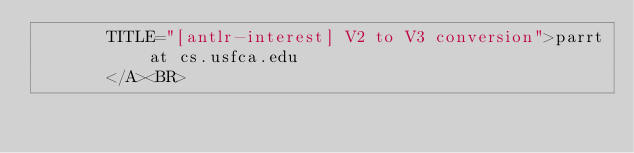Convert code to text. <code><loc_0><loc_0><loc_500><loc_500><_HTML_>       TITLE="[antlr-interest] V2 to V3 conversion">parrt at cs.usfca.edu
       </A><BR></code> 